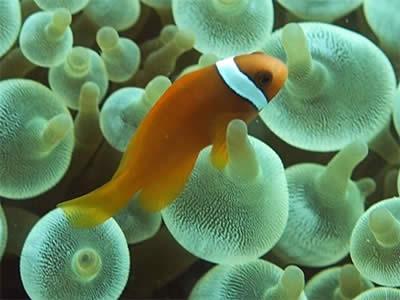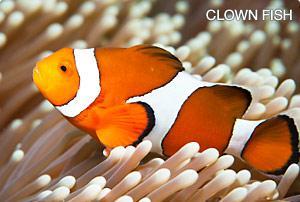The first image is the image on the left, the second image is the image on the right. For the images shown, is this caption "An image includes two orange clownfish." true? Answer yes or no. No. 